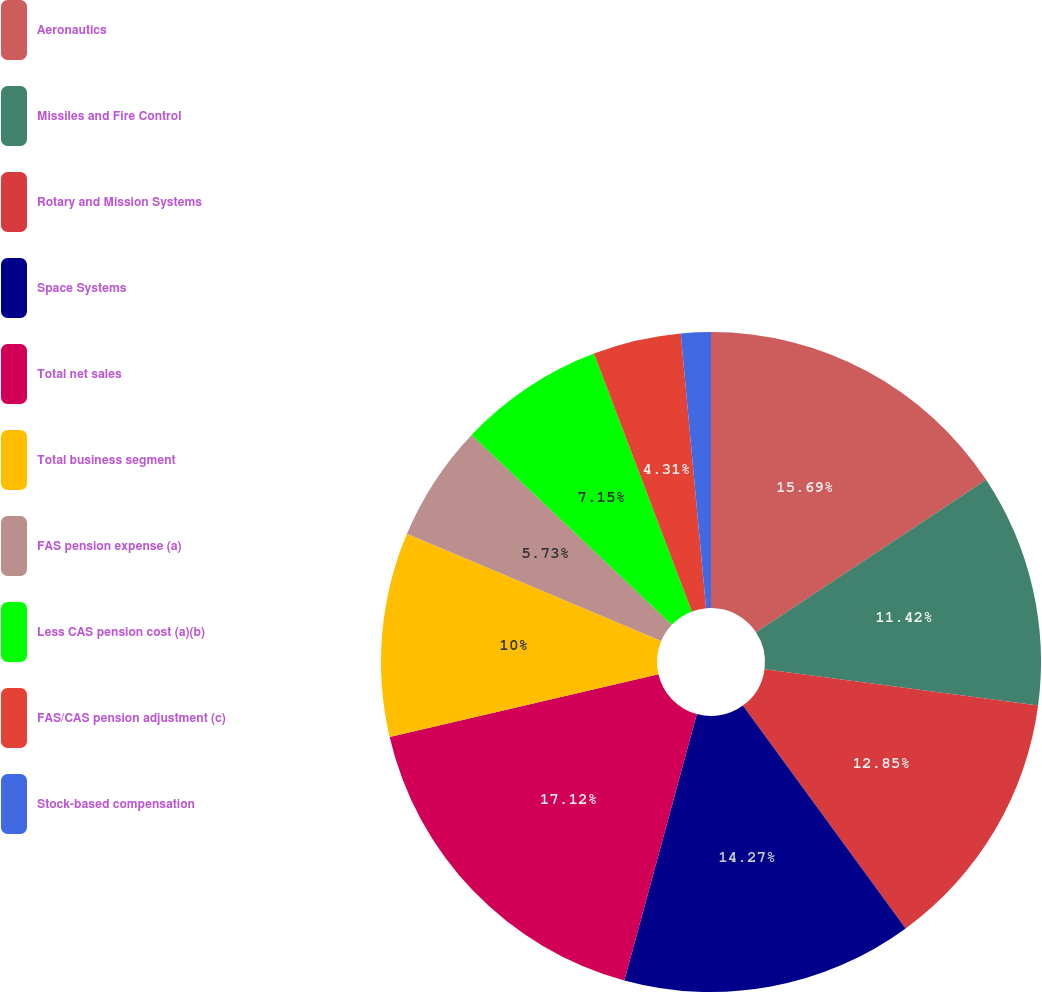Convert chart to OTSL. <chart><loc_0><loc_0><loc_500><loc_500><pie_chart><fcel>Aeronautics<fcel>Missiles and Fire Control<fcel>Rotary and Mission Systems<fcel>Space Systems<fcel>Total net sales<fcel>Total business segment<fcel>FAS pension expense (a)<fcel>Less CAS pension cost (a)(b)<fcel>FAS/CAS pension adjustment (c)<fcel>Stock-based compensation<nl><fcel>15.69%<fcel>11.42%<fcel>12.85%<fcel>14.27%<fcel>17.12%<fcel>10.0%<fcel>5.73%<fcel>7.15%<fcel>4.31%<fcel>1.46%<nl></chart> 